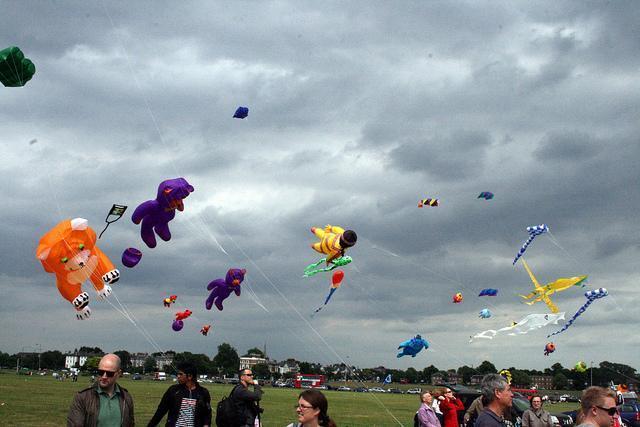How many kites are there?
Give a very brief answer. 3. How many people can be seen?
Give a very brief answer. 2. 